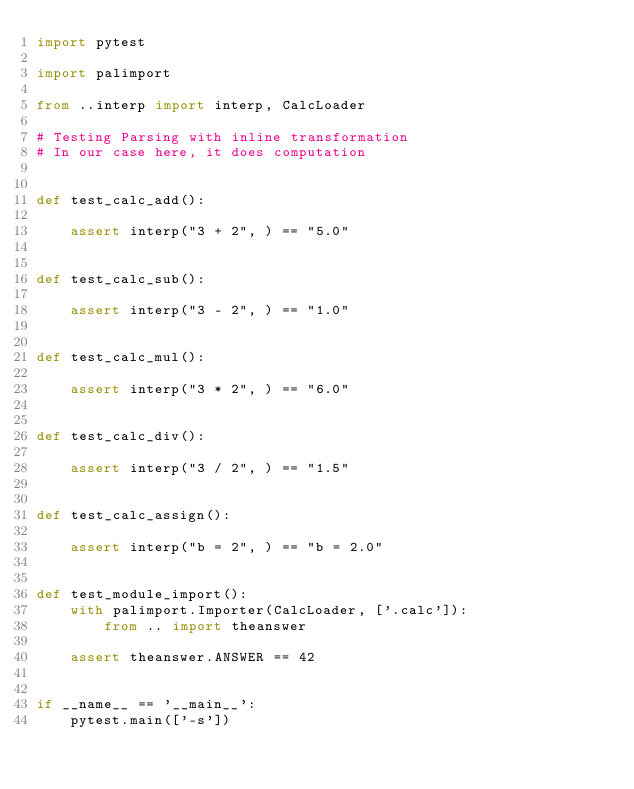<code> <loc_0><loc_0><loc_500><loc_500><_Python_>import pytest

import palimport

from ..interp import interp, CalcLoader

# Testing Parsing with inline transformation
# In our case here, it does computation


def test_calc_add():

    assert interp("3 + 2", ) == "5.0"


def test_calc_sub():

    assert interp("3 - 2", ) == "1.0"


def test_calc_mul():

    assert interp("3 * 2", ) == "6.0"


def test_calc_div():

    assert interp("3 / 2", ) == "1.5"


def test_calc_assign():

    assert interp("b = 2", ) == "b = 2.0"


def test_module_import():
    with palimport.Importer(CalcLoader, ['.calc']):
        from .. import theanswer

    assert theanswer.ANSWER == 42


if __name__ == '__main__':
    pytest.main(['-s'])
</code> 